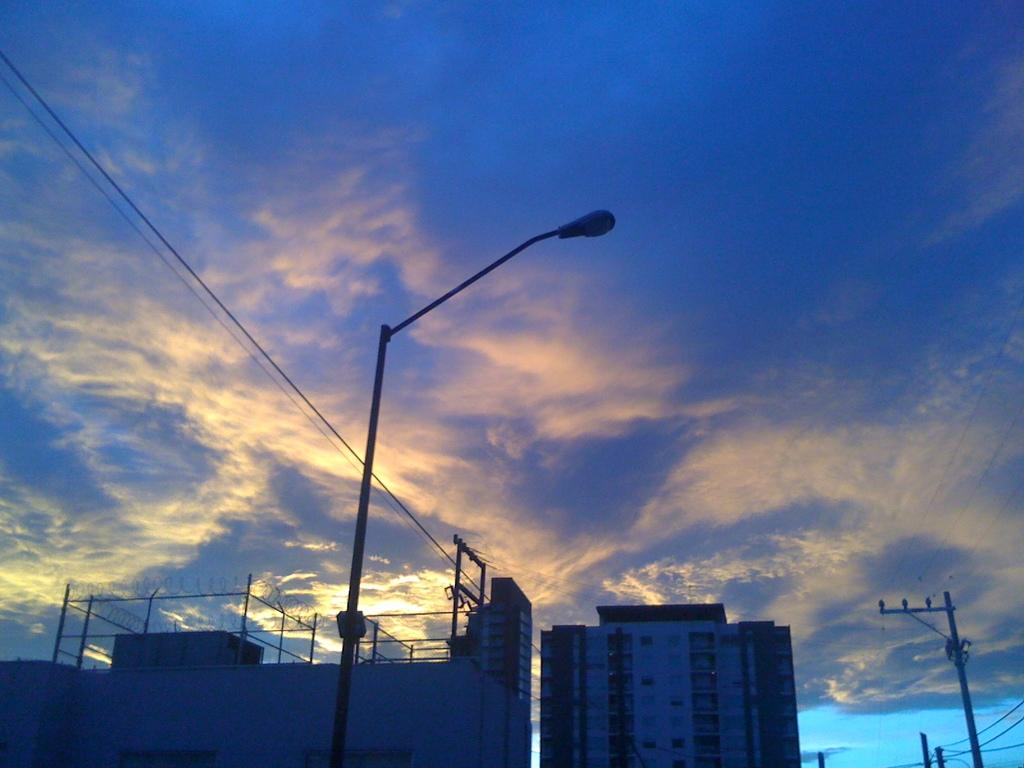What structures are located at the bottom of the image? There are buildings at the bottom of the image. What objects can be seen in the image besides the buildings? There are poles in the image. What is present in the background of the image? There are wires and the sky visible in the background of the image. Can you see any quince trees in the image? There are no quince trees present in the image. How do the poles join together in the image? The poles do not join together in the image; they are separate objects. 